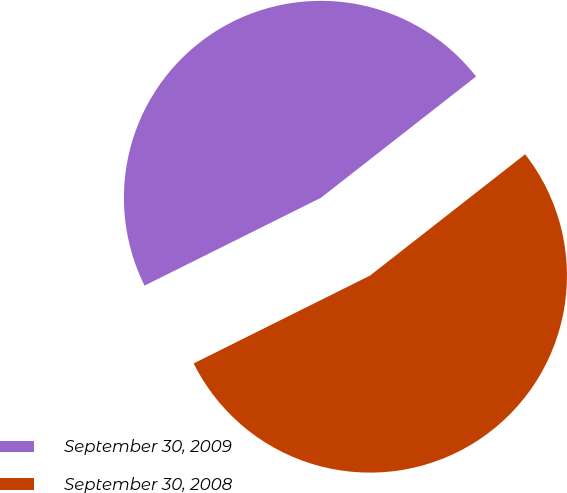<chart> <loc_0><loc_0><loc_500><loc_500><pie_chart><fcel>September 30, 2009<fcel>September 30, 2008<nl><fcel>46.79%<fcel>53.21%<nl></chart> 